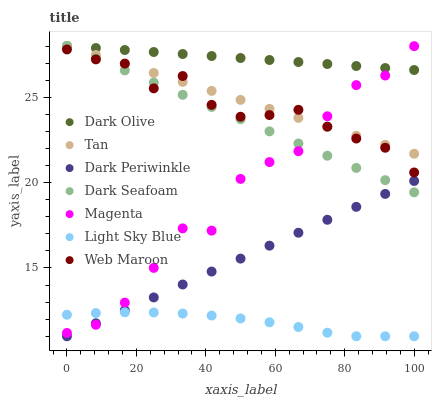Does Light Sky Blue have the minimum area under the curve?
Answer yes or no. Yes. Does Dark Olive have the maximum area under the curve?
Answer yes or no. Yes. Does Web Maroon have the minimum area under the curve?
Answer yes or no. No. Does Web Maroon have the maximum area under the curve?
Answer yes or no. No. Is Dark Olive the smoothest?
Answer yes or no. Yes. Is Magenta the roughest?
Answer yes or no. Yes. Is Web Maroon the smoothest?
Answer yes or no. No. Is Web Maroon the roughest?
Answer yes or no. No. Does Dark Periwinkle have the lowest value?
Answer yes or no. Yes. Does Web Maroon have the lowest value?
Answer yes or no. No. Does Tan have the highest value?
Answer yes or no. Yes. Does Web Maroon have the highest value?
Answer yes or no. No. Is Dark Periwinkle less than Web Maroon?
Answer yes or no. Yes. Is Dark Olive greater than Dark Periwinkle?
Answer yes or no. Yes. Does Dark Seafoam intersect Dark Periwinkle?
Answer yes or no. Yes. Is Dark Seafoam less than Dark Periwinkle?
Answer yes or no. No. Is Dark Seafoam greater than Dark Periwinkle?
Answer yes or no. No. Does Dark Periwinkle intersect Web Maroon?
Answer yes or no. No. 